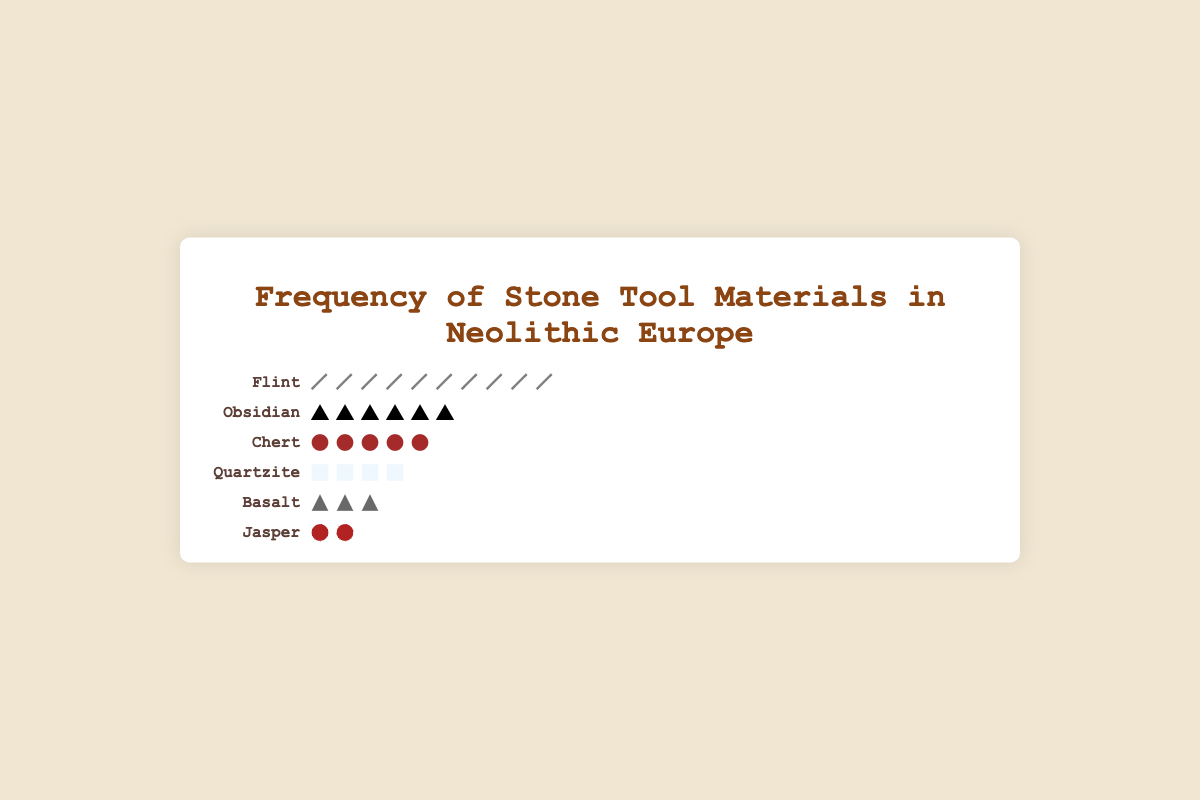What is the most frequently found stone tool material in Neolithic Europe? The figure shows the frequency of different stone tool materials using icons. The material with the highest number of icons represents the highest frequency. Flint has the most icons.
Answer: Flint How many times more frequent is Flint compared to Jasper? Count the icons for Flint and Jasper. Flint has 10 icons, and Jasper has 2 icons. 10 divided by 2 equals 5.
Answer: 5 times What is the sum of the frequencies for Chert and Quartzite? Count the icons for Chert and Quartzite. Chert has 5 icons, and Quartzite has 4 icons. Sum them up: 5 + 4 = 9.
Answer: 9 Which material has a mid-level frequency in the dataset? Arrange materials by the number of icons from most to least. Flint (10), Obsidian (6), Chert (5), Quartzite (4), Basalt (3), Jasper (2). Chert, as the middle value, represents a mid-level frequency.
Answer: Chert Is Obsidian more or less frequent than Quartzite? Compare the number of icons for Obsidian and Quartzite. Obsidian has 6 icons, Quartzite has 4 icons. Obsidian is more frequent.
Answer: More frequent Which stone tool material is the least frequent? The material with the fewest icons represents the least frequency. Jasper has the least number of icons.
Answer: Jasper How many total icons are used in the Isotype Plot to represent all materials? Count all icons for each material: Flint (10), Obsidian (6), Chert (5), Quartzite (4), Basalt (3), Jasper (2). Sum them up: 10 + 6 + 5 + 4 + 3 + 2 = 30.
Answer: 30 If you sum the frequencies of Basalt and Jasper, how does it compare to the frequency of Obsidian? Basalt has 3 icons, Jasper has 2 icons, summing them gives 3 + 2 = 5. Obsidian has 6 icons. Comparing 5 to 6 shows the sum is less.
Answer: Less Which two materials combined have roughly the same frequency as Flint? Flint has 10 icons. Look for two materials whose combined icons approximate 10. Obsidian (6) + Quartzite (4) or Obsidian (6) + Chert (5) exceed slightly, but the first pair is closer.
Answer: Obsidian and Quartzite Arrange the stone tool materials from least to most frequent. List materials by increasing number of icons: Jasper (2), Basalt (3), Quartzite (4), Chert (5), Obsidian (6), Flint (10).
Answer: Jasper, Basalt, Quartzite, Chert, Obsidian, Flint 